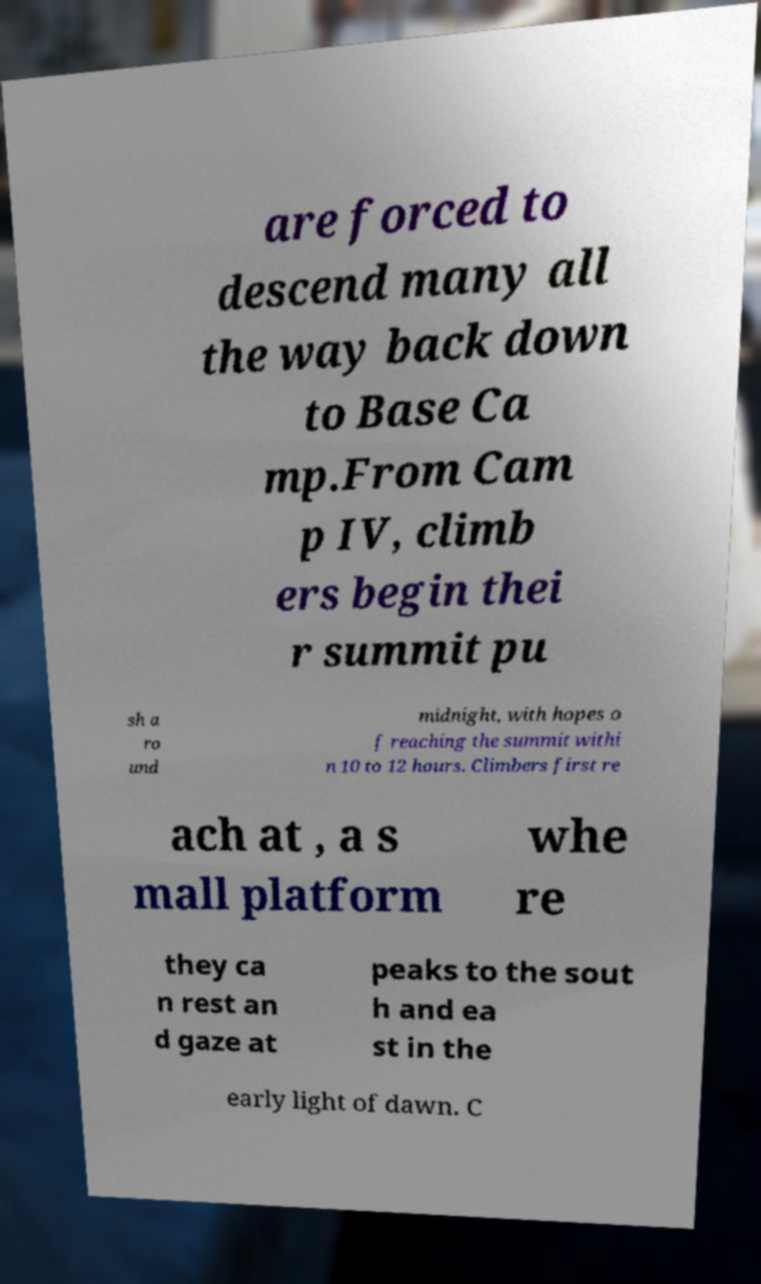There's text embedded in this image that I need extracted. Can you transcribe it verbatim? are forced to descend many all the way back down to Base Ca mp.From Cam p IV, climb ers begin thei r summit pu sh a ro und midnight, with hopes o f reaching the summit withi n 10 to 12 hours. Climbers first re ach at , a s mall platform whe re they ca n rest an d gaze at peaks to the sout h and ea st in the early light of dawn. C 